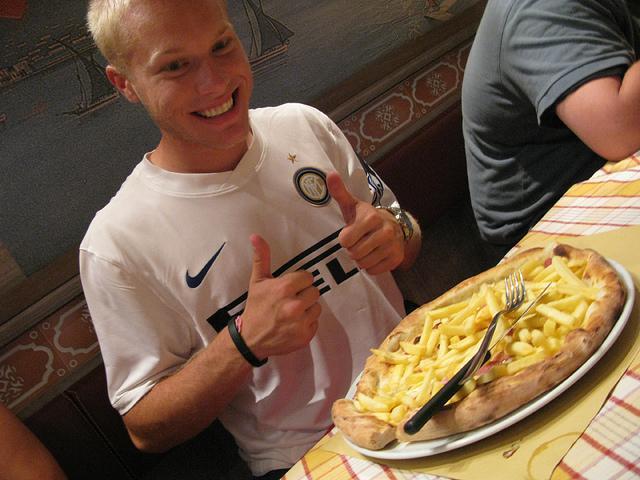How many people are visible?
Give a very brief answer. 3. 